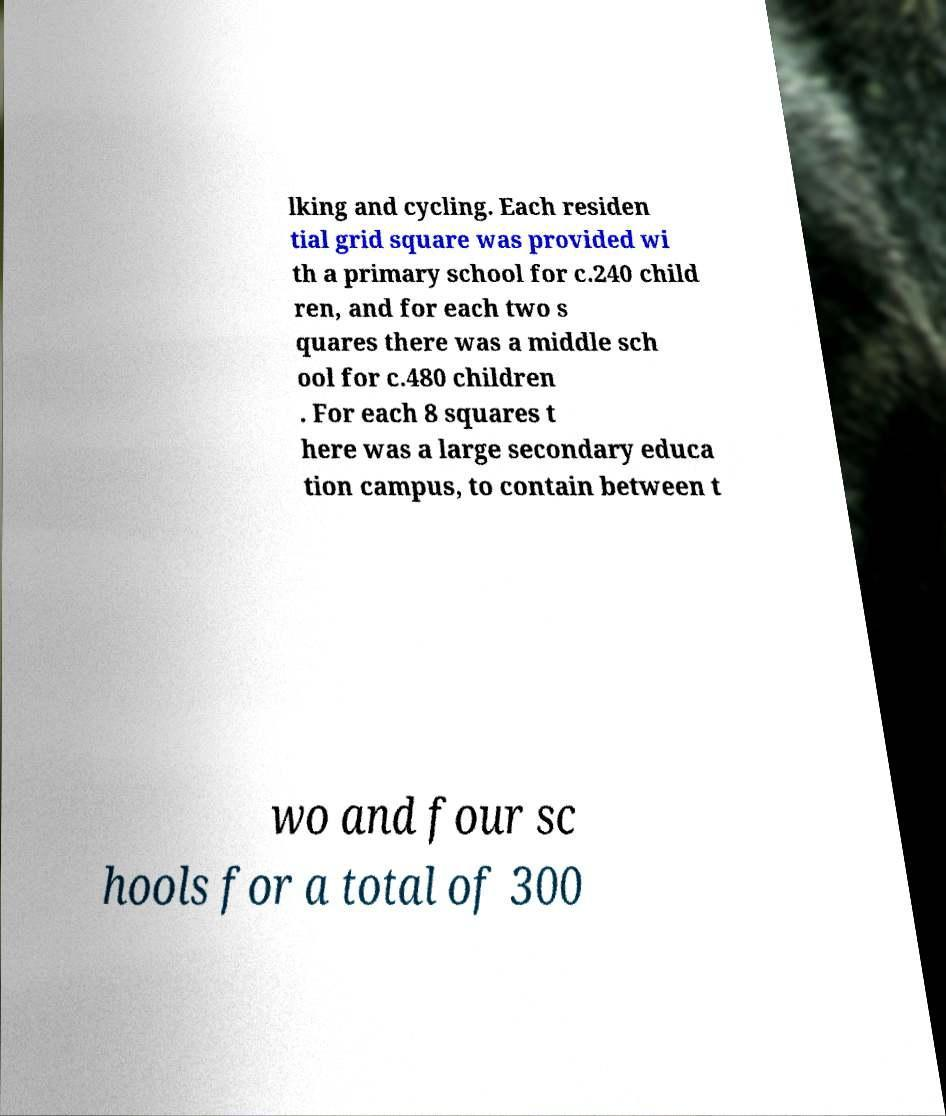I need the written content from this picture converted into text. Can you do that? lking and cycling. Each residen tial grid square was provided wi th a primary school for c.240 child ren, and for each two s quares there was a middle sch ool for c.480 children . For each 8 squares t here was a large secondary educa tion campus, to contain between t wo and four sc hools for a total of 300 